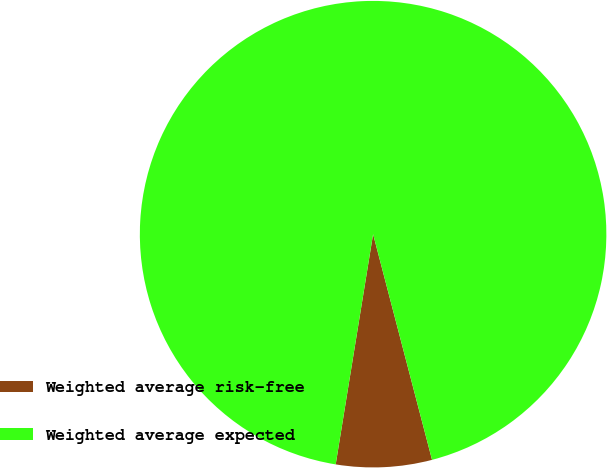Convert chart to OTSL. <chart><loc_0><loc_0><loc_500><loc_500><pie_chart><fcel>Weighted average risk-free<fcel>Weighted average expected<nl><fcel>6.63%<fcel>93.37%<nl></chart> 